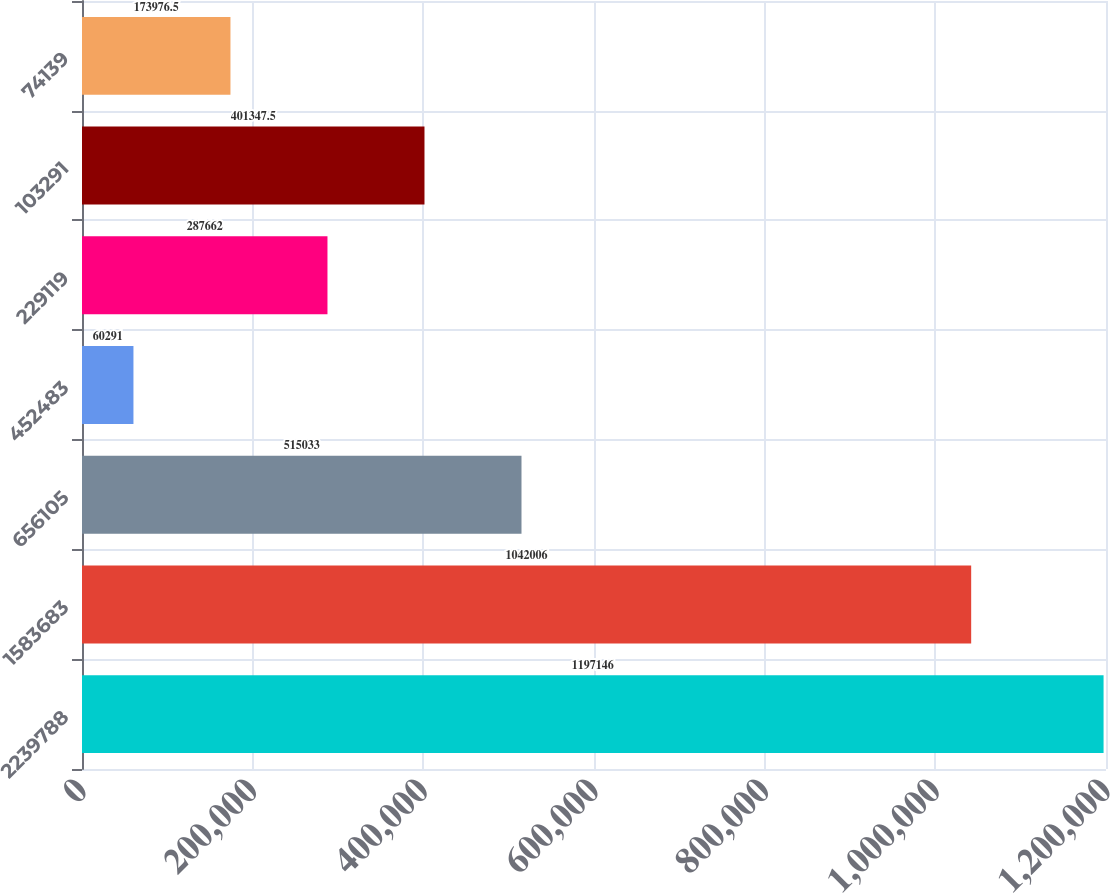Convert chart to OTSL. <chart><loc_0><loc_0><loc_500><loc_500><bar_chart><fcel>2239788<fcel>1583683<fcel>656105<fcel>452483<fcel>229119<fcel>103291<fcel>74139<nl><fcel>1.19715e+06<fcel>1.04201e+06<fcel>515033<fcel>60291<fcel>287662<fcel>401348<fcel>173976<nl></chart> 